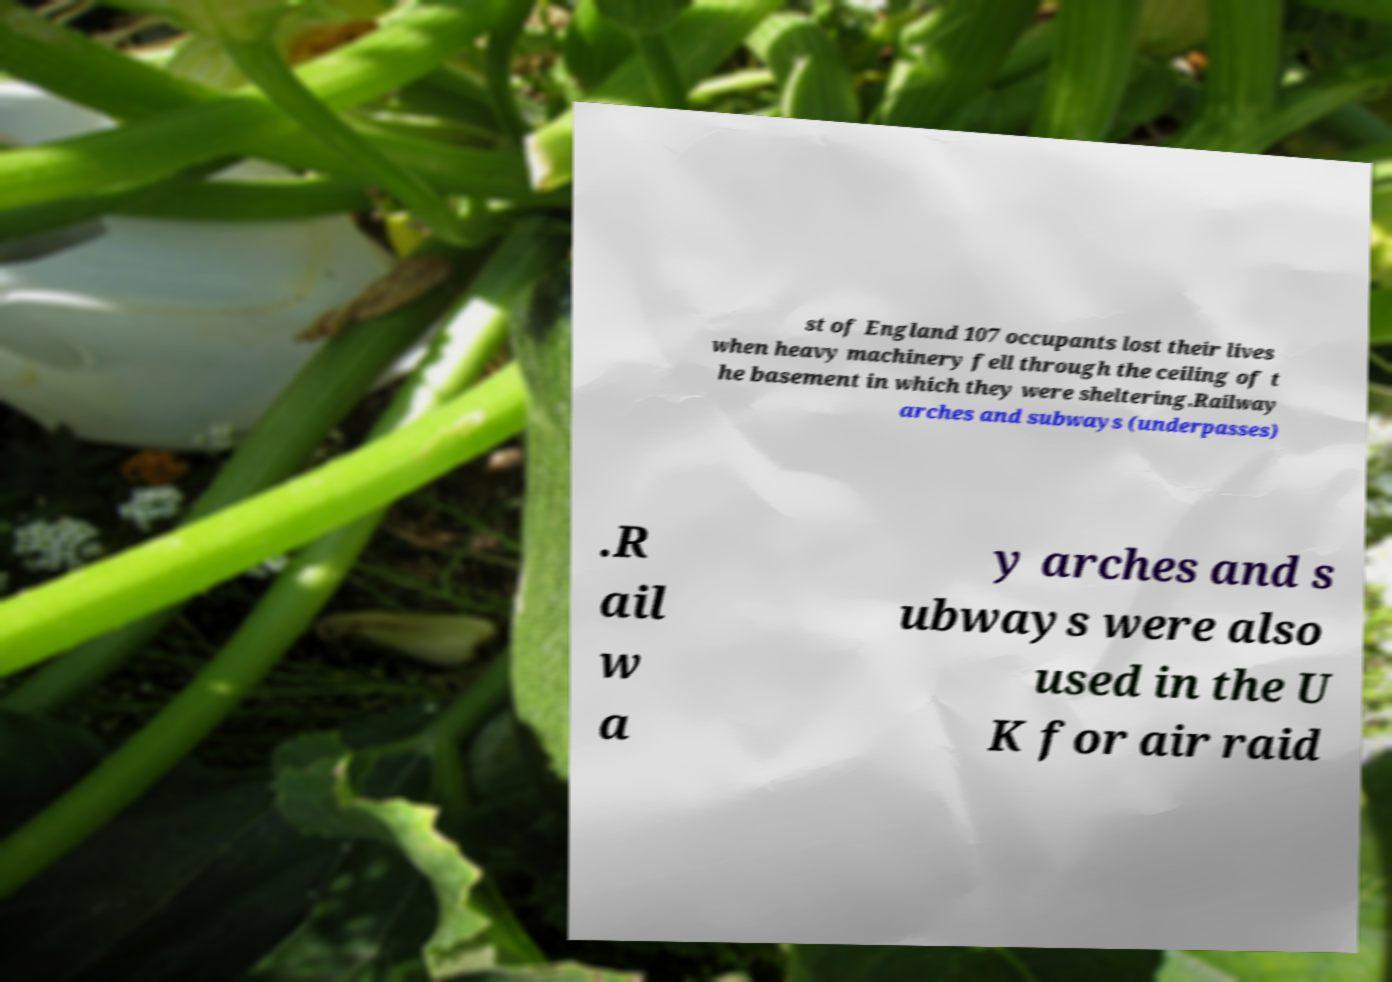Could you extract and type out the text from this image? st of England 107 occupants lost their lives when heavy machinery fell through the ceiling of t he basement in which they were sheltering.Railway arches and subways (underpasses) .R ail w a y arches and s ubways were also used in the U K for air raid 